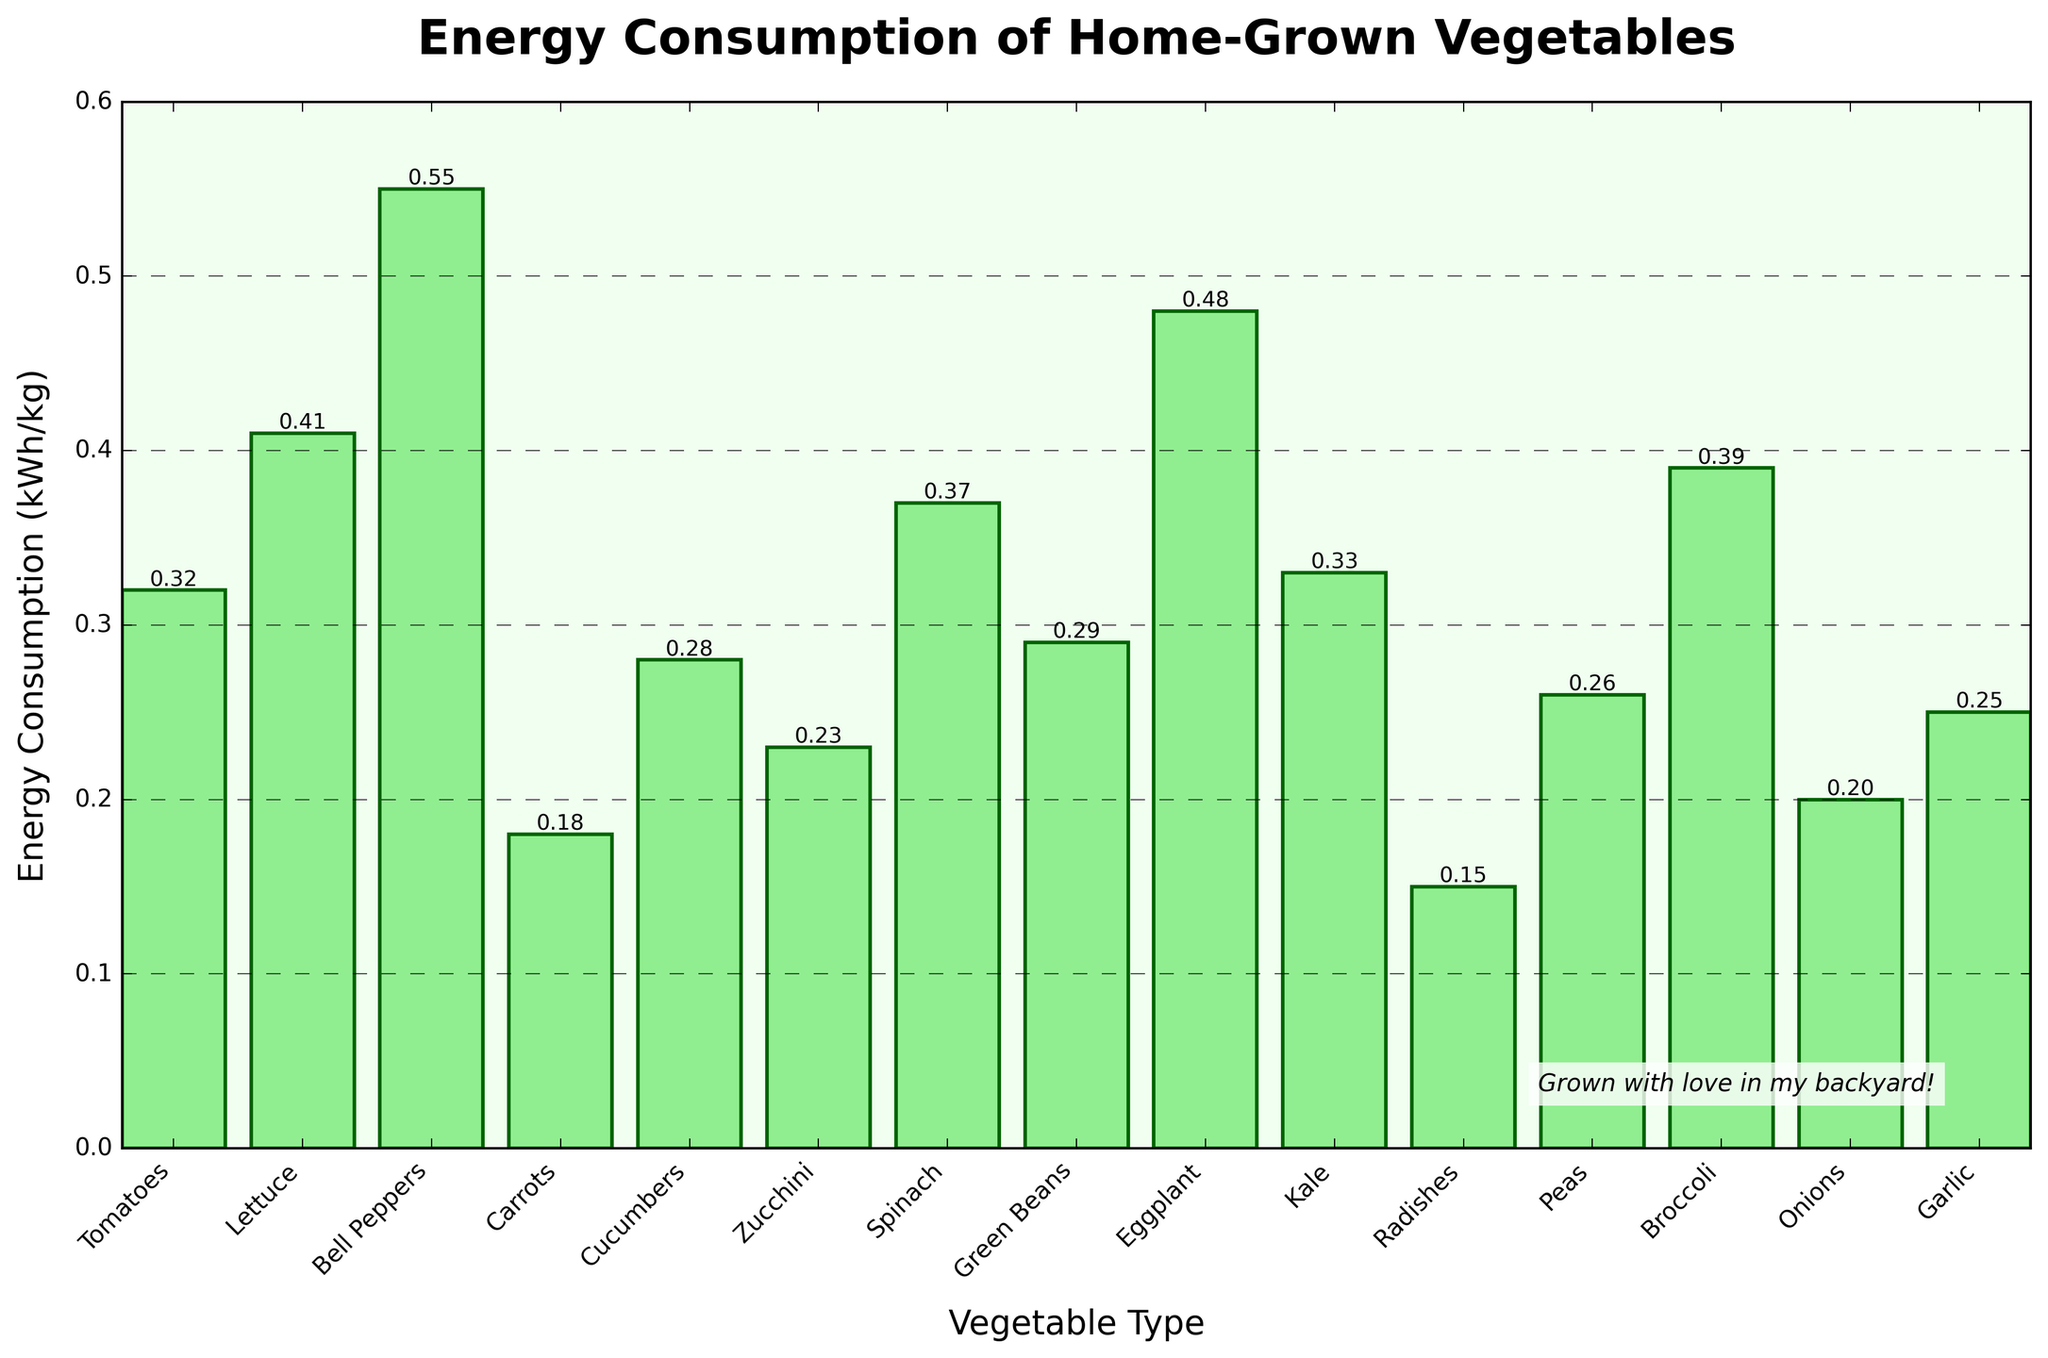What's the vegetable with the lowest energy consumption? The vegetable with the lowest bar represents the lowest energy consumption. Looking at the figure, the bar for Radishes is the shortest.
Answer: Radishes What's the difference in energy consumption between Bell Peppers and Carrots? Find the height of the bars for Bell Peppers and Carrots and subtract the value of Carrots from Bell Peppers. Bell Peppers' energy consumption is 0.55 kWh/kg, and Carrots' is 0.18 kWh/kg. The difference is 0.55 - 0.18 = 0.37 kWh/kg.
Answer: 0.37 kWh/kg Which vegetable has a higher energy consumption, Spinach or Cucumbers? Compare the heights of the bars for Spinach and Cucumbers. Spinach is taller with an energy consumption of 0.37 kWh/kg, whereas Cucumbers have 0.28 kWh/kg.
Answer: Spinach What's the sum of the energy consumption for Kale, Peas, and Onions? Add the heights of the bars for Kale, Peas, and Onions. Kale = 0.33 kWh/kg, Peas = 0.26 kWh/kg, and Onions = 0.20 kWh/kg. The sum is 0.33 + 0.26 + 0.20 = 0.79 kWh/kg.
Answer: 0.79 kWh/kg Which vegetables have an energy consumption below 0.30 kWh/kg? Identify bars that are shorter than the 0.30 kWh/kg mark. These vegetables are Carrots (0.18), Cucumbers (0.28), Zucchini (0.23), Green Beans (0.29), Radishes (0.15), Peas (0.26), Onions (0.20), and Garlic (0.25).
Answer: Carrots, Cucumbers, Zucchini, Green Beans, Radishes, Peas, Onions, Garlic Is the energy consumption of Bell Peppers greater than the combined energy consumption of Broccoli and Garlic? Compare Bell Peppers' value with the sum of Broccoli and Garlic. Bell Peppers = 0.55 kWh/kg, Broccoli = 0.39 kWh/kg, Garlic = 0.25 kWh/kg. Sum = 0.39 + 0.25 = 0.64 kWh/kg. 0.55 kWh/kg is less than 0.64 kWh/kg.
Answer: No What is the average energy consumption of Tomatoes, Lettuce, and Eggplant? Sum the heights of the bars for Tomatoes, Lettuce, and Eggplant and divide by 3. Tomatoes = 0.32 kWh/kg, Lettuce = 0.41 kWh/kg, Eggplant = 0.48 kWh/kg. Sum = 0.32 + 0.41 + 0.48 = 1.21 kWh/kg. Average = 1.21/3 = 0.403 kWh/kg.
Answer: 0.403 kWh/kg How does the energy consumption of Zucchini compare to that of Kale? Look at the heights of the bars for Zucchini and Kale. Zucchini has 0.23 kWh/kg, and Kale has 0.33 kWh/kg. Zucchini's energy consumption is lower.
Answer: Zucchini is lower What's the total energy consumption of all vegetables shown? Add up the heights of all the bars. Sum = 0.32 + 0.41 + 0.55 + 0.18 + 0.28 + 0.23 + 0.37 + 0.29 + 0.48 + 0.33 + 0.15 + 0.26 + 0.39 + 0.20 + 0.25 = 4.69 kWh/kg.
Answer: 4.69 kWh/kg 